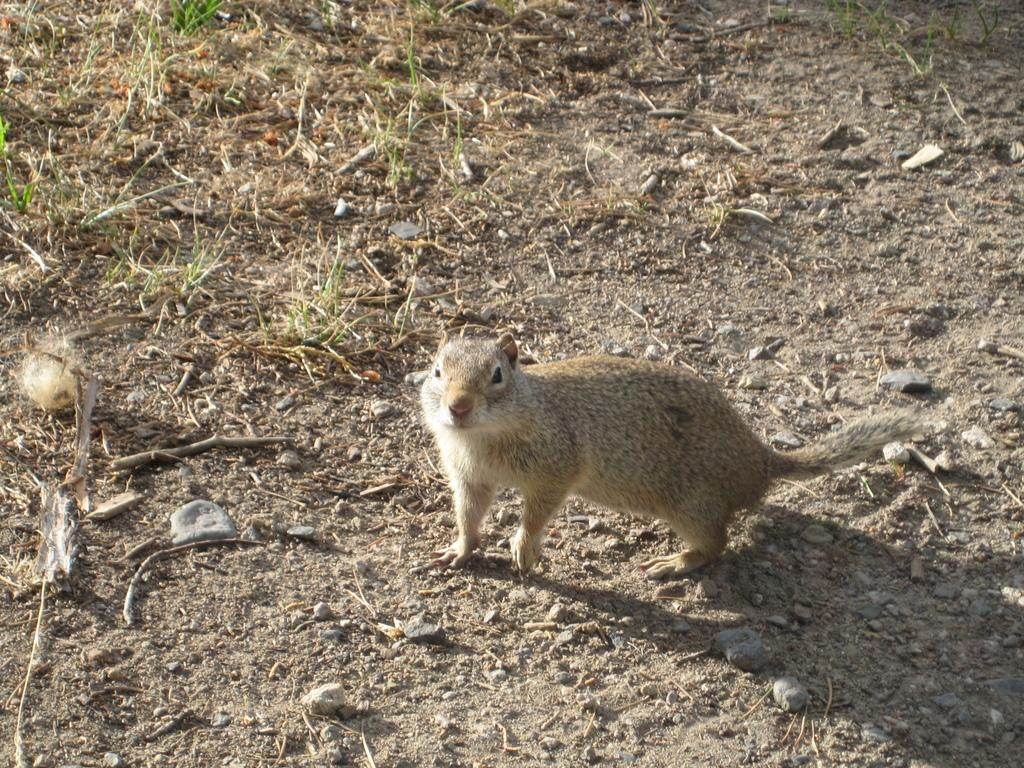What type of animal is in the image? There is a squirrel in the image. Where is the squirrel located in the image? The squirrel is in the middle of the image. What type of drum is the squirrel playing in the image? There is no drum present in the image; it features a squirrel in the middle. 